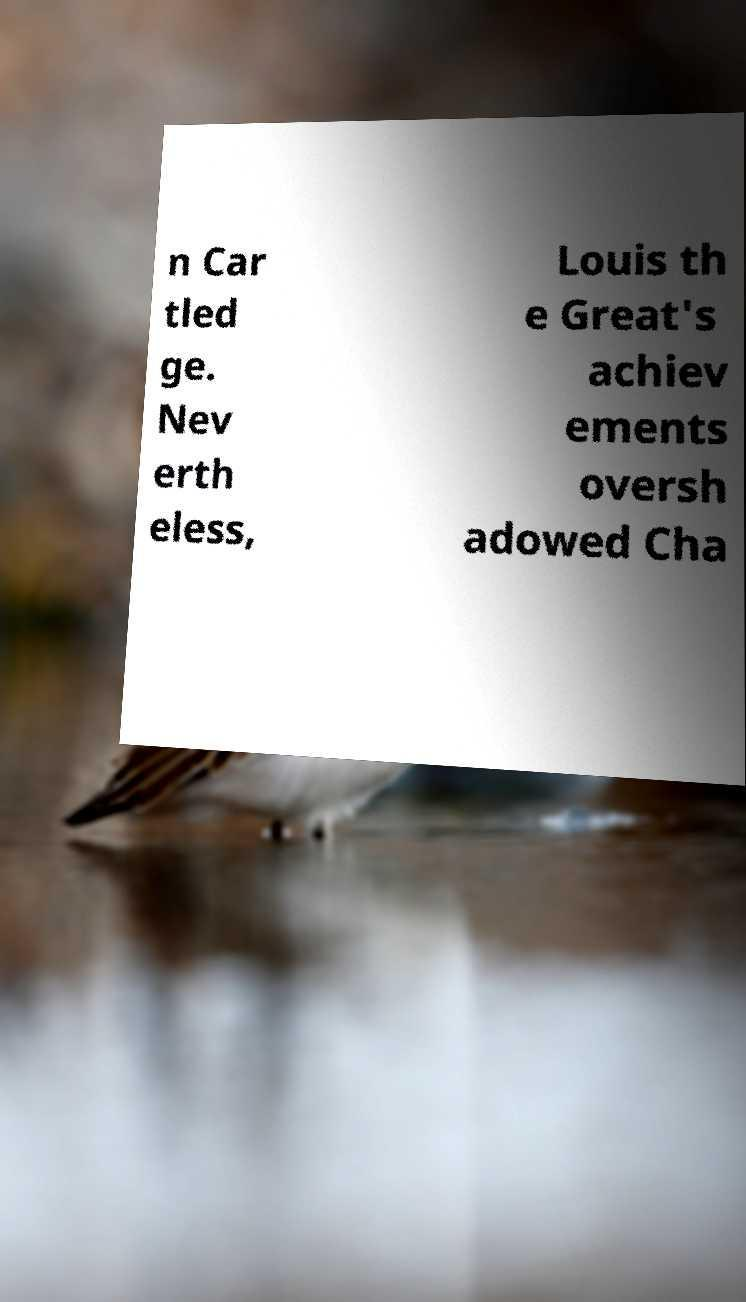Please identify and transcribe the text found in this image. n Car tled ge. Nev erth eless, Louis th e Great's achiev ements oversh adowed Cha 